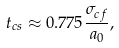<formula> <loc_0><loc_0><loc_500><loc_500>t _ { c s } \approx 0 . 7 7 5 \frac { \sigma _ { c f } } { a _ { 0 } } ,</formula> 